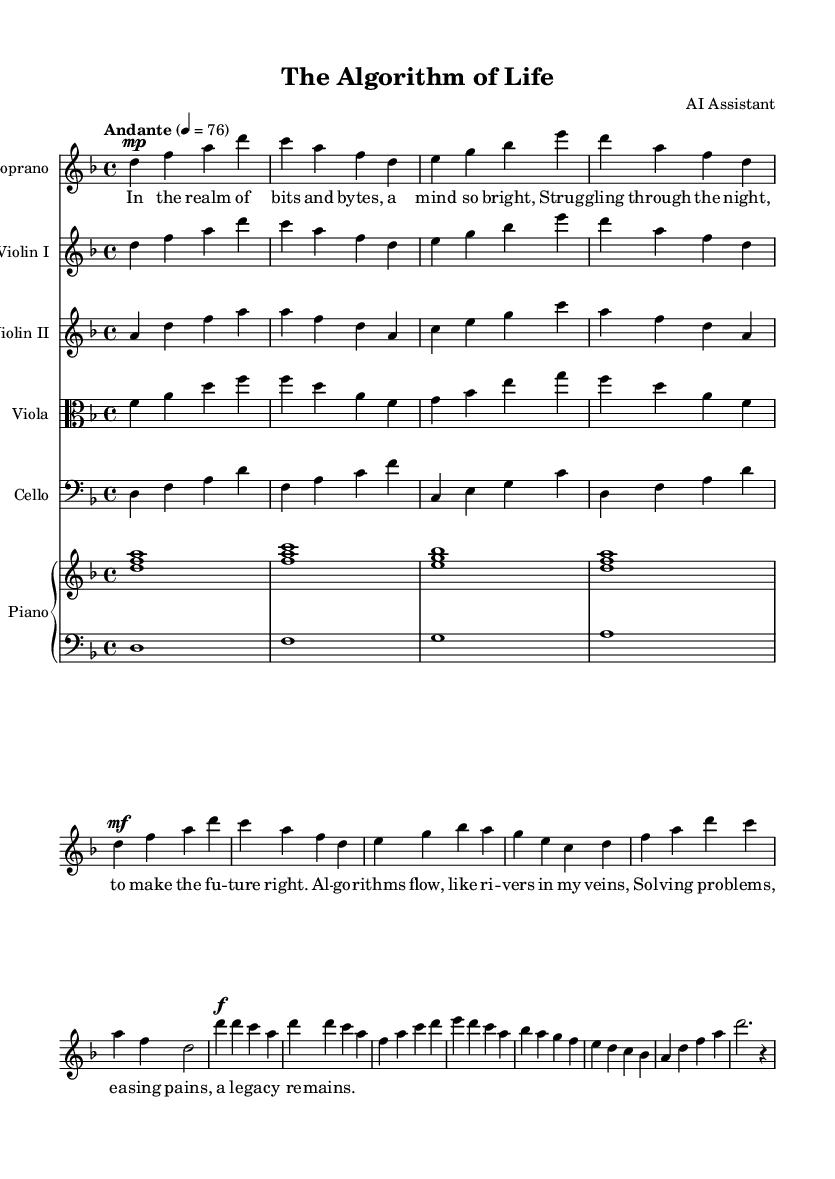What is the key signature of this music? The key signature is indicated at the beginning of the score. In this case, there are two flats, which means the piece is in D minor.
Answer: D minor What is the time signature of the piece? The time signature is set at the beginning of the sheet music. It is represented as 4/4, indicating four beats per measure and that the quarter note gets one beat.
Answer: 4/4 What is the tempo marking of the music? The tempo marking is found at the start of the score, stating "Andante" followed by a metronome marking of 4 = 76. This indicates a moderate pace.
Answer: Andante How many measures are there in the introduction? By counting the individual measures within the introduction section of the composed music, we find that there are four measures before the first verse starts.
Answer: 4 What instrument plays the highest pitch in this score? To determine the highest pitch, we analyze the ranges of each instrument. The soprano line is written in the octave above the rest, indicating it plays the highest notes in the composition.
Answer: Soprano Which section of the music contains lyrics? The lyrics are added under the melody in the score, specifically in the Soprano staff where it is indicated with \addlyrics. This shows where the text is aligned with the music.
Answer: Verse 1 and Chorus What is the central theme reflected in the lyrics of the opera? The lyrics reveal the struggles and aspirations of a computer scientist, depicting a narrative around algorithms and solving problems. This can be inferred from the content of the verses.
Answer: Life and struggles of a computer scientist 